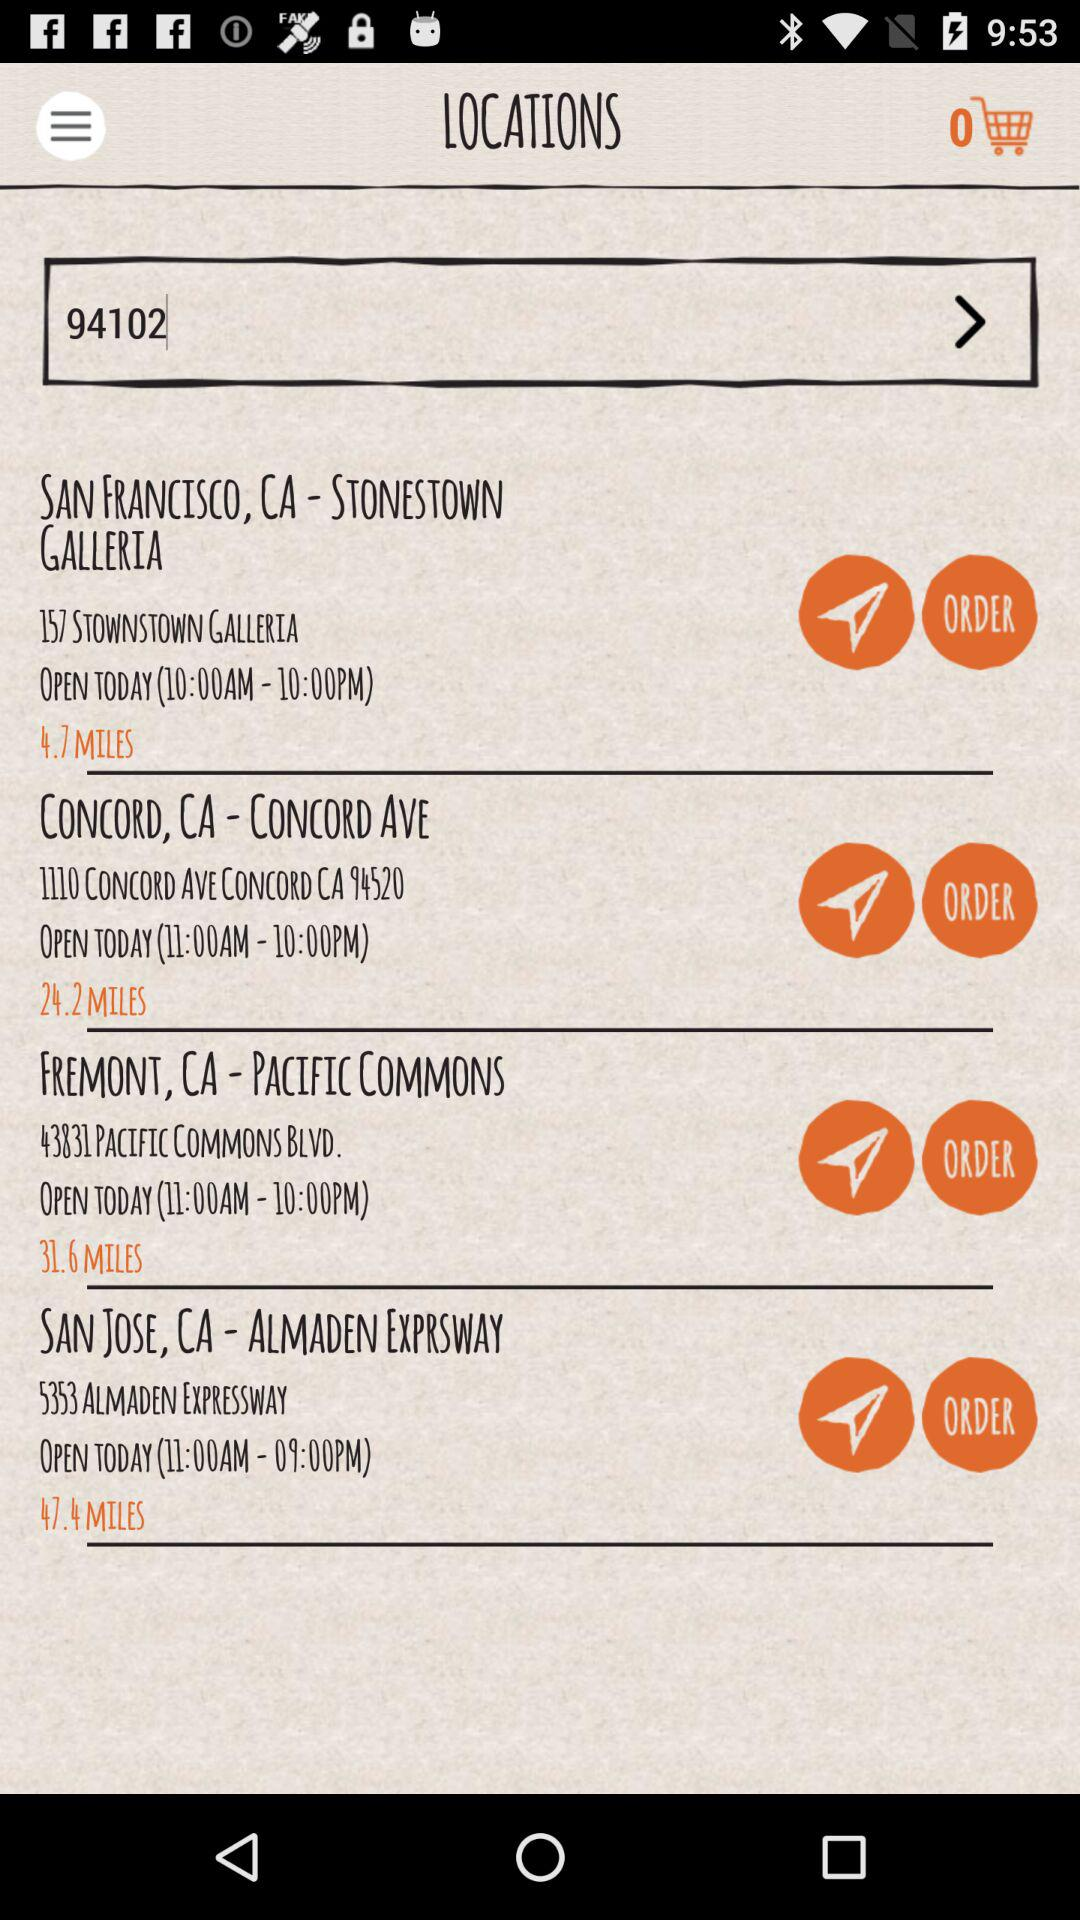What is the distance between San Jose, CA - Almaden Exprsway and my location? The distance between San Jose, CA - Almaden Exprsway and my location is 47.4 miles. 